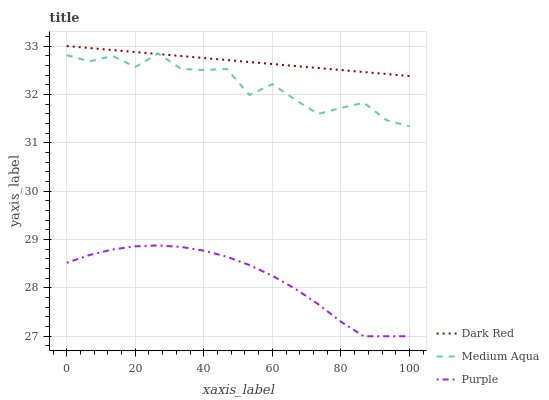Does Purple have the minimum area under the curve?
Answer yes or no. Yes. Does Dark Red have the maximum area under the curve?
Answer yes or no. Yes. Does Medium Aqua have the minimum area under the curve?
Answer yes or no. No. Does Medium Aqua have the maximum area under the curve?
Answer yes or no. No. Is Dark Red the smoothest?
Answer yes or no. Yes. Is Medium Aqua the roughest?
Answer yes or no. Yes. Is Medium Aqua the smoothest?
Answer yes or no. No. Is Dark Red the roughest?
Answer yes or no. No. Does Purple have the lowest value?
Answer yes or no. Yes. Does Medium Aqua have the lowest value?
Answer yes or no. No. Does Dark Red have the highest value?
Answer yes or no. Yes. Does Medium Aqua have the highest value?
Answer yes or no. No. Is Purple less than Dark Red?
Answer yes or no. Yes. Is Dark Red greater than Purple?
Answer yes or no. Yes. Does Medium Aqua intersect Dark Red?
Answer yes or no. Yes. Is Medium Aqua less than Dark Red?
Answer yes or no. No. Is Medium Aqua greater than Dark Red?
Answer yes or no. No. Does Purple intersect Dark Red?
Answer yes or no. No. 